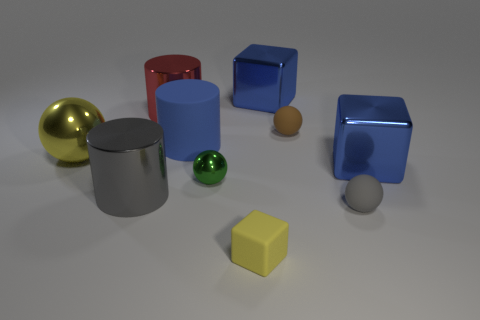Subtract all spheres. How many objects are left? 6 Add 1 tiny brown spheres. How many tiny brown spheres exist? 2 Subtract 1 red cylinders. How many objects are left? 9 Subtract all purple rubber blocks. Subtract all large blue shiny blocks. How many objects are left? 8 Add 7 big balls. How many big balls are left? 8 